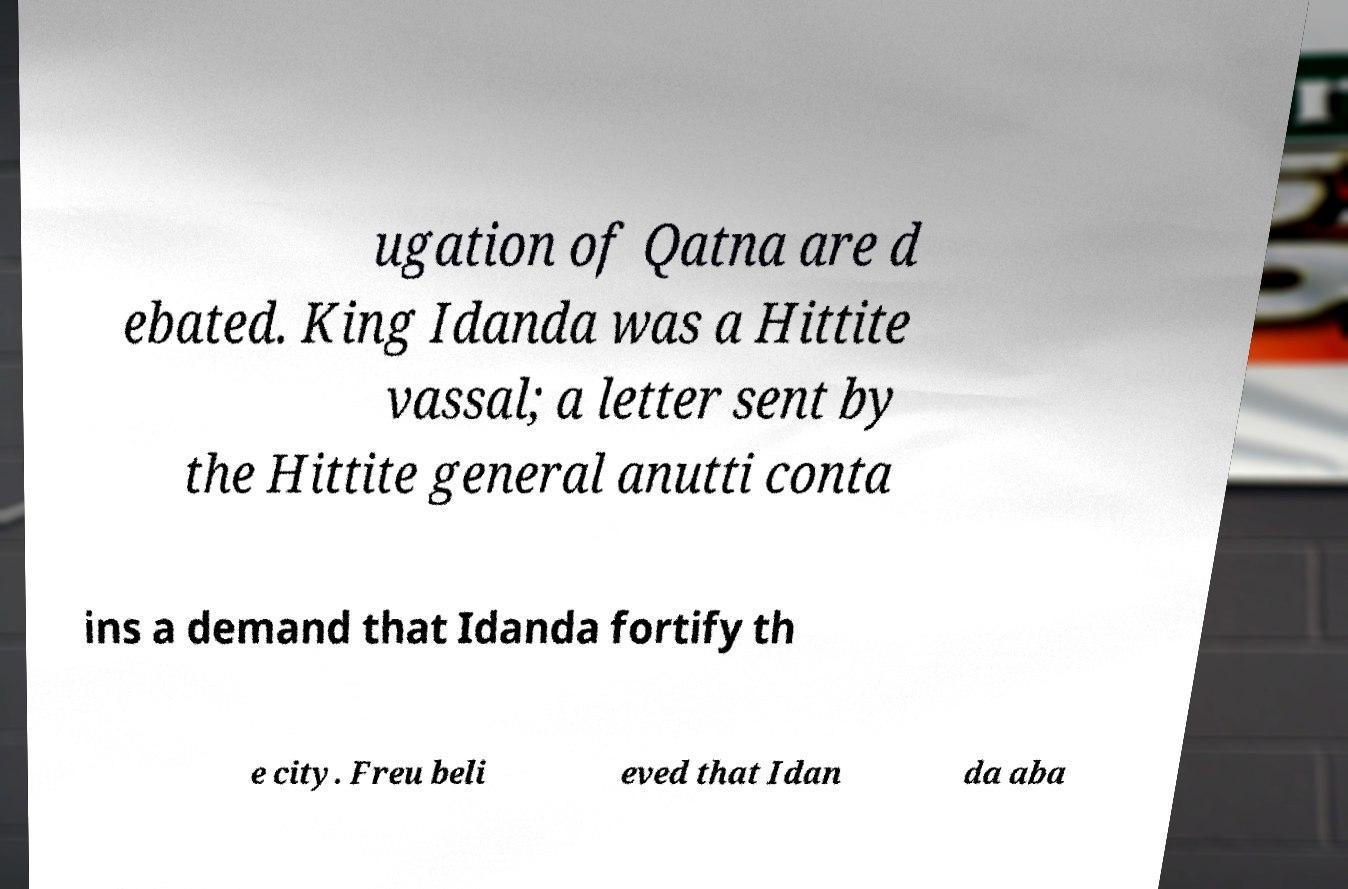Could you extract and type out the text from this image? ugation of Qatna are d ebated. King Idanda was a Hittite vassal; a letter sent by the Hittite general anutti conta ins a demand that Idanda fortify th e city. Freu beli eved that Idan da aba 